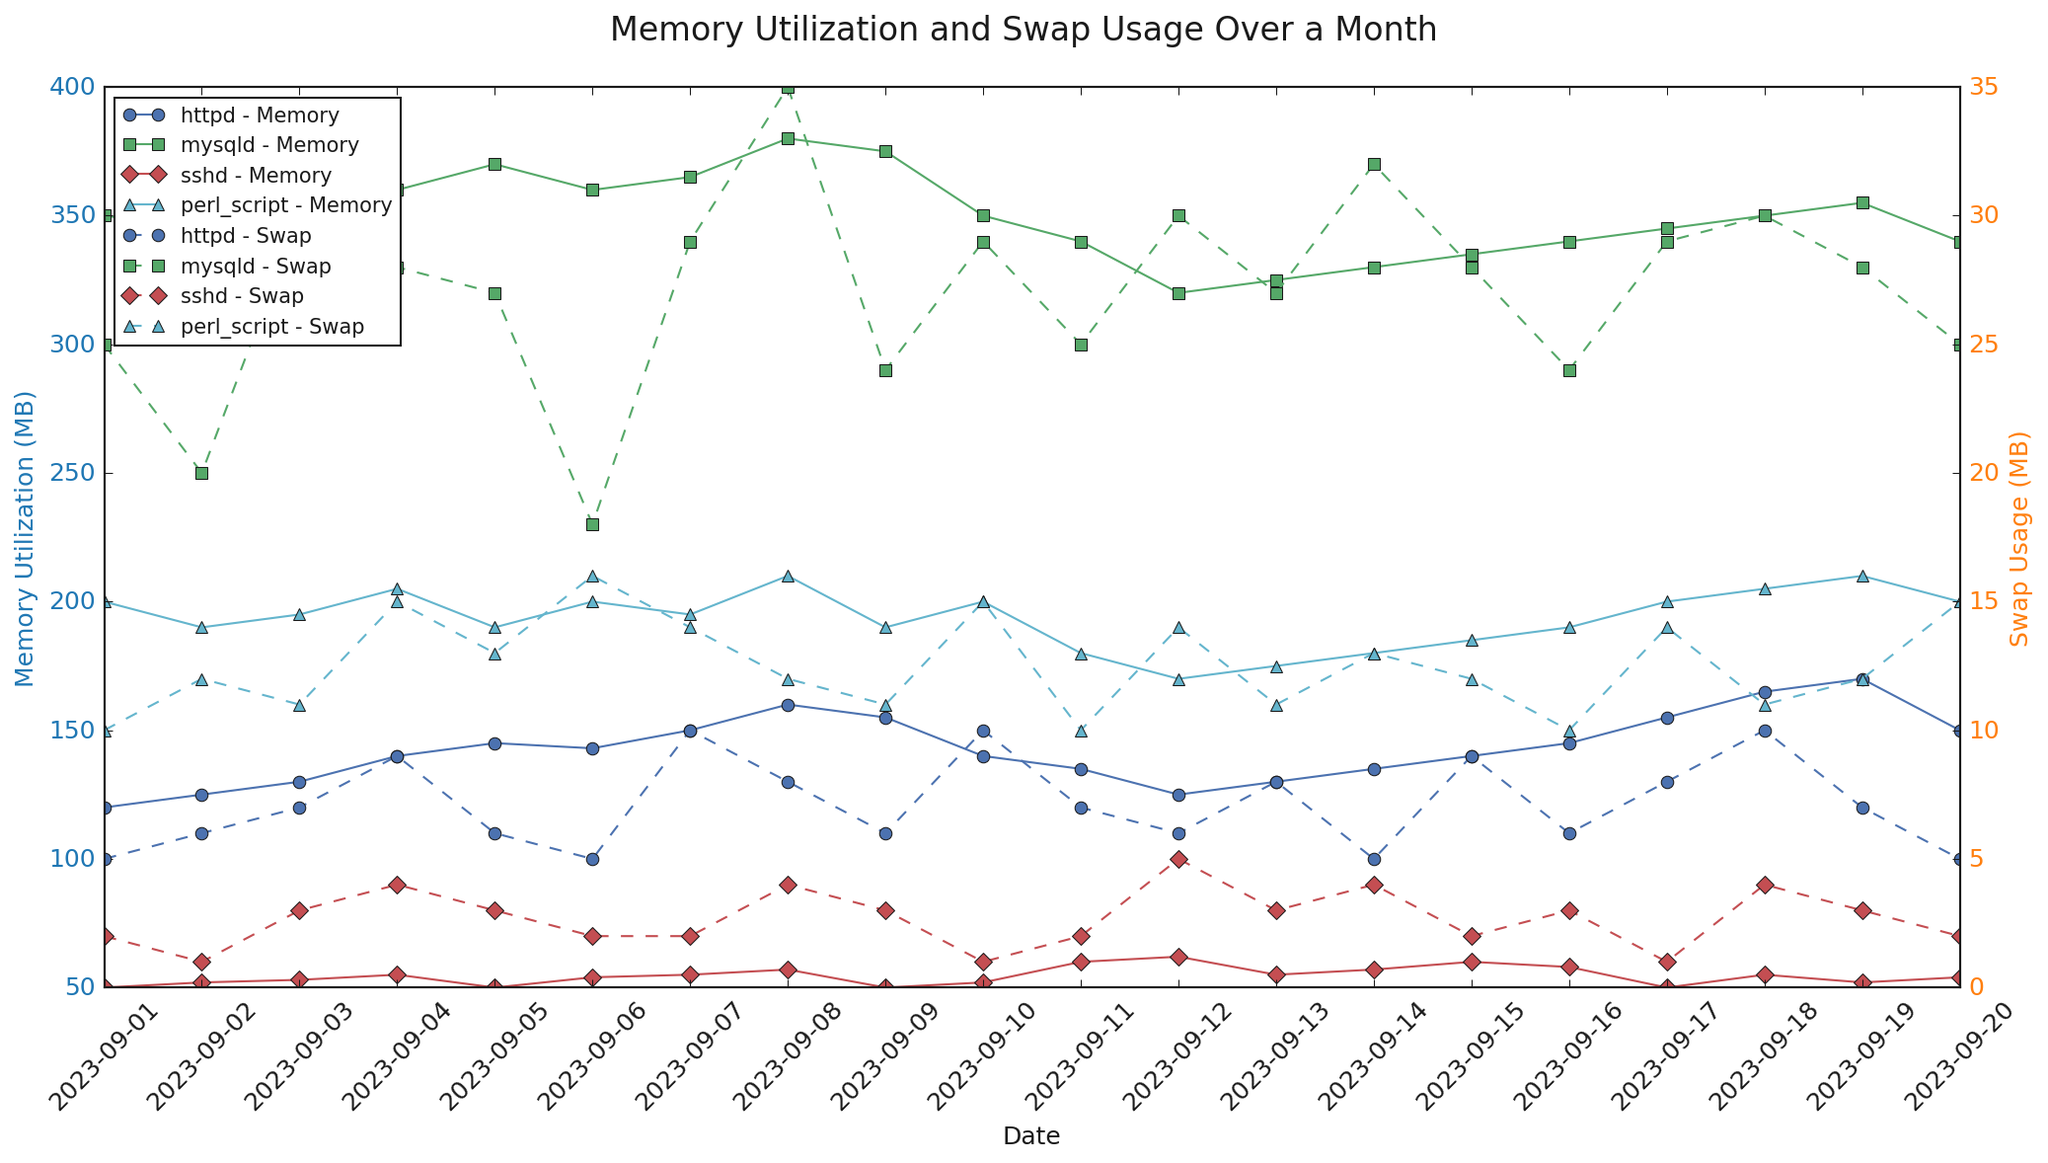What's the highest recorded memory utilization for the httpd process? Look at the line representing httpd's memory utilization and find the highest peak. This peak occurs on 2023-09-18 with a value of 165 MB.
Answer: 165 MB Which process had the highest swap usage on 2023-09-08? Identify each process's swap usage on 2023-09-08 and compare the values. The highest value is for mysqld with 35 MB.
Answer: mysqld What is the average memory utilization of the mysqld process over the month? Sum the daily memory utilization values for mysqld and divide by the number of days. Summing the values (350, 345, 355, 360, 370, 360, 365, 380, 375, 350, 340, 320, 325, 330, 335, 340, 345, 350, 355, 340) gives 6925. Dividing by 20 days gives 6925/20 = 346.25 MB.
Answer: 346.25 MB Compare the swap usage trends of httpd and perl_script processes. Which one has higher fluctuations? Observe the trend lines (dashed) for both processes in swap usage. The swap usage for perl_script shows more variability with frequent increases and decreases.
Answer: perl_script On which date did the sshd process reach its peak memory utilization and what was the value? Find the highest point on the line representing sshd's memory utilization and note the corresponding date. The peak occurs on 2023-09-11 with a value of 60 MB.
Answer: 2023-09-11, 60 MB How does the swap usage of the mysqld process on 2023-09-12 compare to its memory utilization on the same day? Note the values for mysqld's swap usage and memory utilization on 2023-09-12. Swap usage is 30 MB and memory utilization is 320 MB.
Answer: Swap usage is 30 MB and memory utilization is 320 MB What is the difference in memory utilization between the highest and lowest recording days for the perl_script process? Identify the highest (2023-09-08, 210 MB) and lowest (2023-09-12, 170 MB) memory utilization for perl_script. Subtract the lowest value from the highest. 210 MB - 170 MB = 40 MB.
Answer: 40 MB 